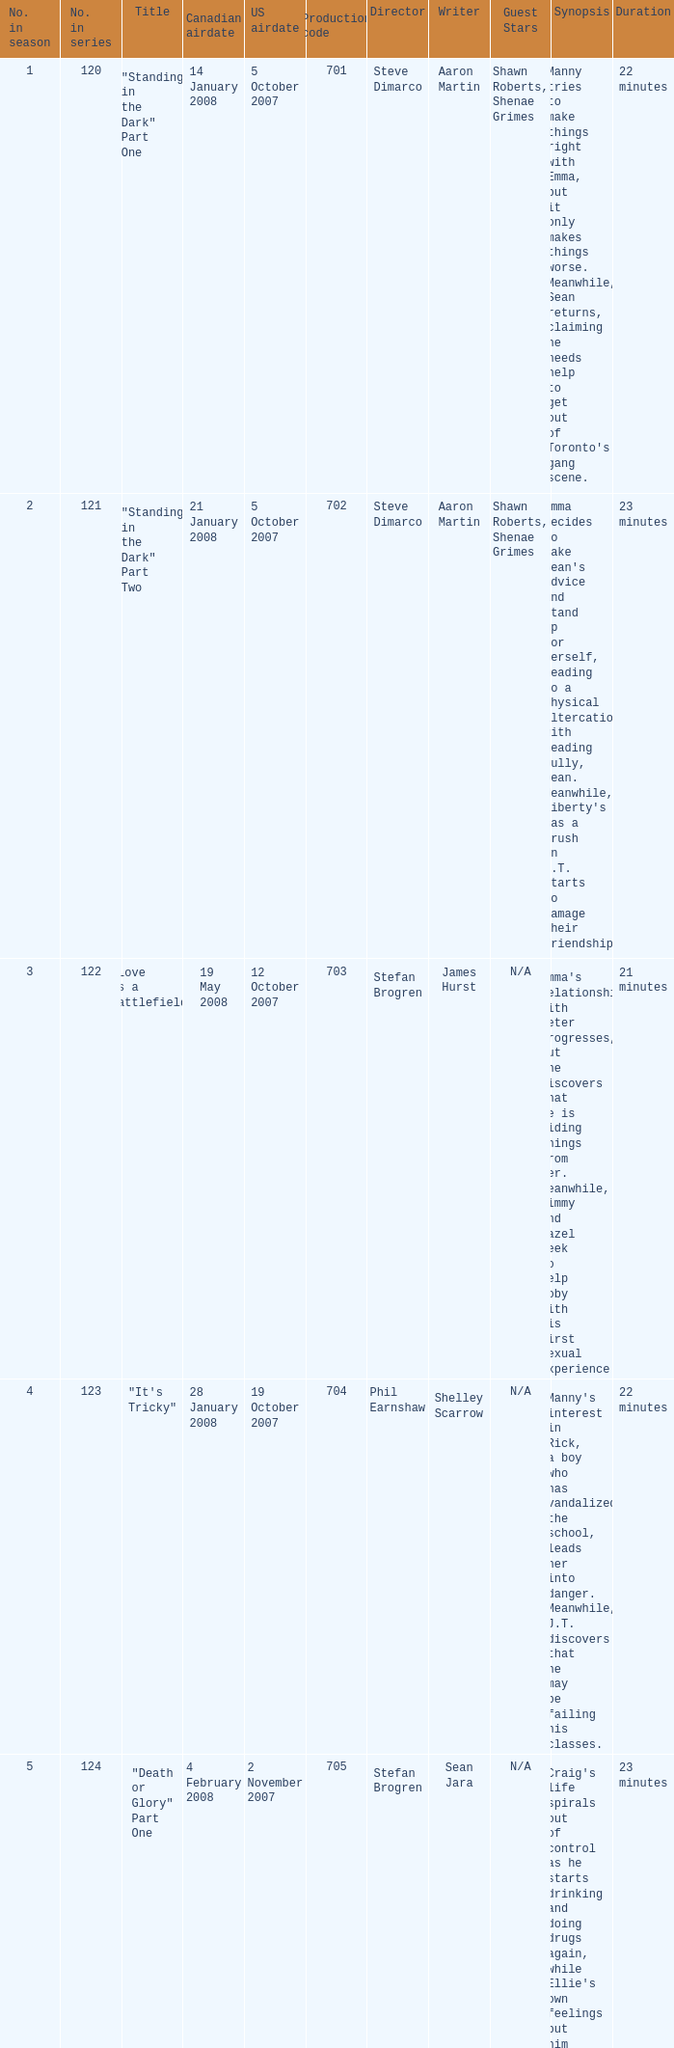The U.S. airdate of 4 april 2008 had a production code of what? 714.0. 